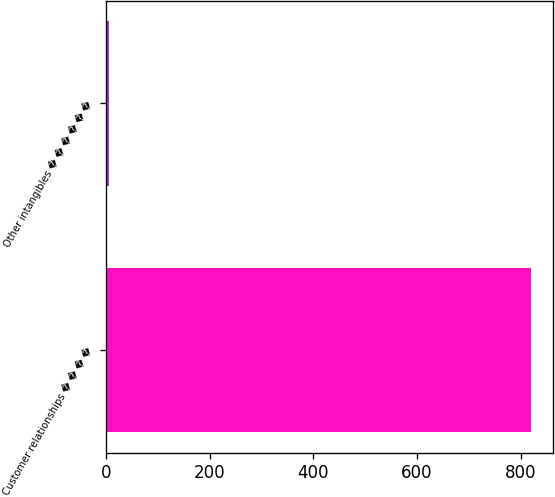Convert chart to OTSL. <chart><loc_0><loc_0><loc_500><loc_500><bar_chart><fcel>Customer relationships � � � �<fcel>Other intangibles � � � � � �<nl><fcel>821<fcel>5<nl></chart> 